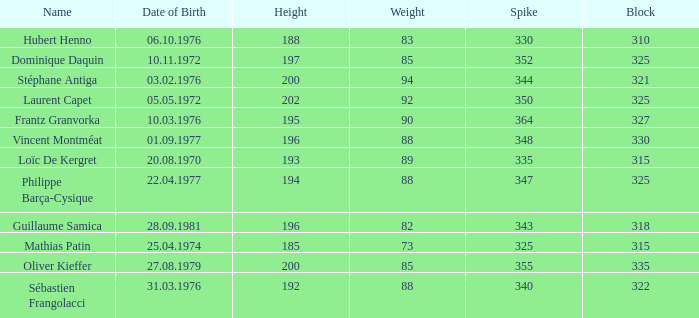How many spikes feature 2 None. 